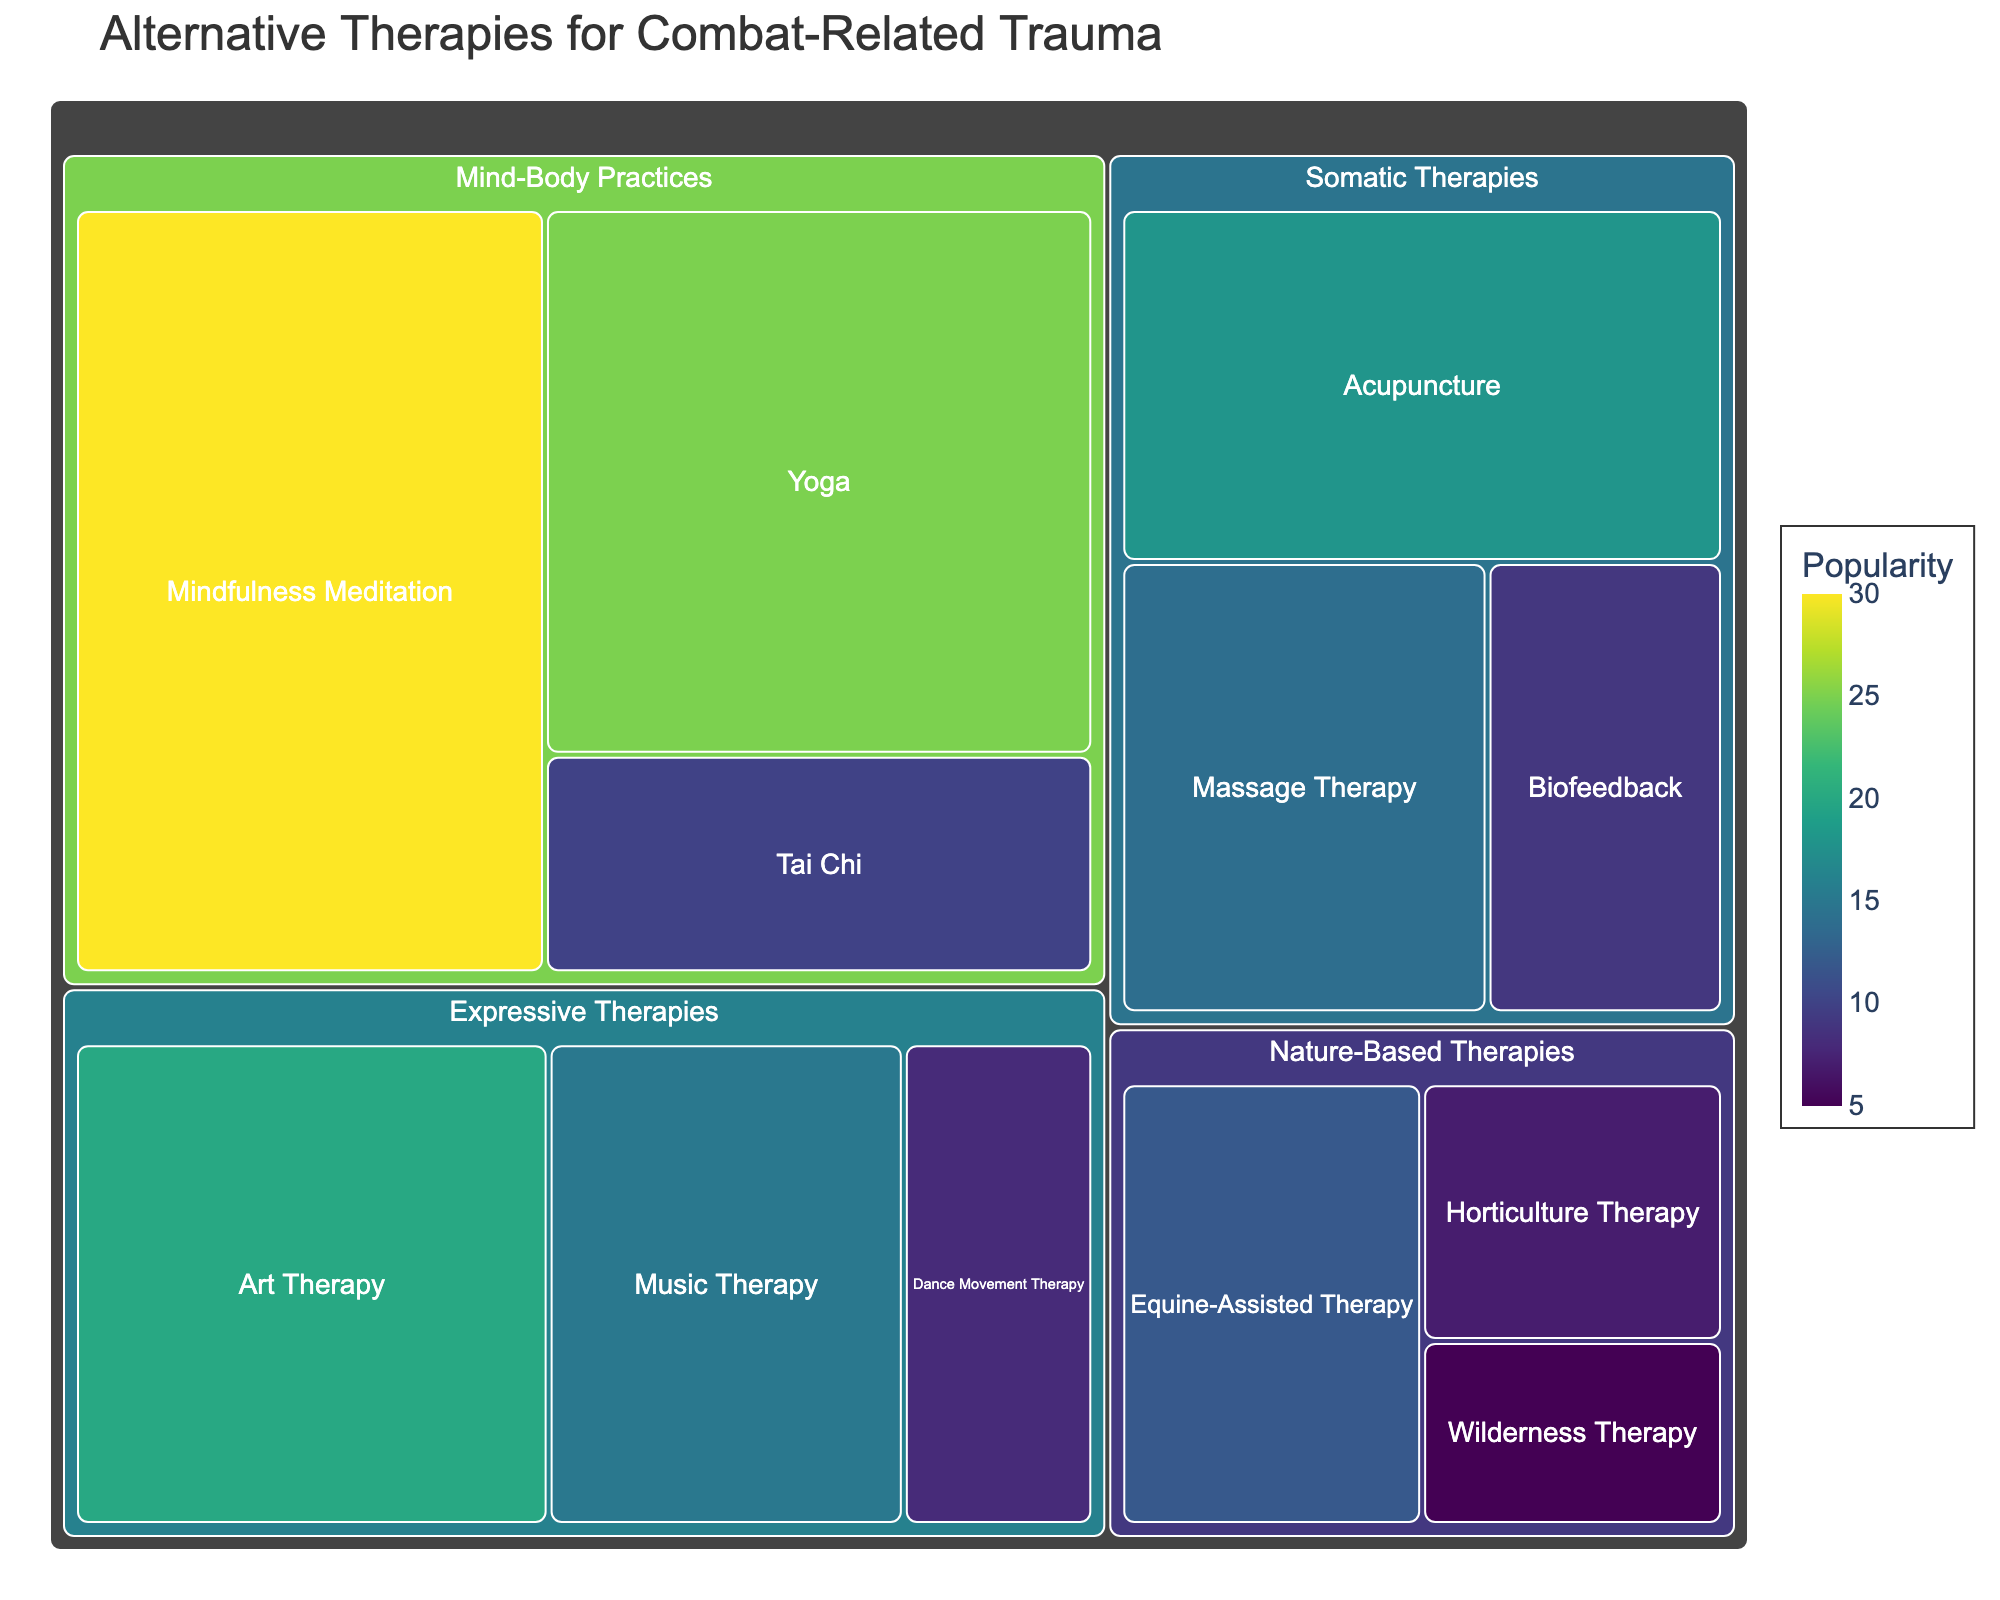Which therapy has the highest popularity among veterans? Look at the largest tile within the Treemap, which indicates the therapy with the highest popularity value. The therapy with the highest popularity is "Mindfulness Meditation" with a popularity score of 30.
Answer: Mindfulness Meditation Which category does "Acupuncture" belong to? Find the tile labeled "Acupuncture" in the Treemap and observe its hierarchical placement. "Acupuncture" belongs to the "Somatic Therapies" category.
Answer: Somatic Therapies What is the combined popularity of all Expressive Therapies? Identify all therapies under the "Expressive Therapies" category and sum up their popularity values: Art Therapy (20) + Music Therapy (15) + Dance Movement Therapy (8). The total is 20 + 15 + 8 = 43.
Answer: 43 Which category has the lowest total popularity among its therapies? Calculate the total popularity for each category. The lowest total can be found by summing the individual popularity scores:
- Mind-Body Practices: 30 + 25 + 10 = 65
- Expressive Therapies: 20 + 15 + 8 = 43
- Nature-Based Therapies: 12 + 7 + 5 = 24
- Somatic Therapies: 18 + 14 + 9 = 41
Nature-Based Therapies has the lowest total popularity of 24.
Answer: Nature-Based Therapies Among therapies in Nature-Based Therapies, which one has the highest popularity? Locate the tiles under "Nature-Based Therapies" and identify the one with the highest popularity value. "Equine-Assisted Therapy" has a popularity score of 12, the highest in this category.
Answer: Equine-Assisted Therapy How many distinct therapies are included in the Treemap? Count each labeled tile within the Treemap to determine the number of distinct therapies. There are 12 distinct therapies.
Answer: 12 Compare the popularity of "Yoga" and "Music Therapy". Which one is more popular? Locate the tiles "Yoga" and "Music Therapy" and compare their popularity values. "Yoga" has a popularity of 25, whereas "Music Therapy" has 15. Therefore, "Yoga" is more popular.
Answer: Yoga What is the average popularity of therapies under Somatic Therapies? Sum the popularity values of therapies in the "Somatic Therapies" category and divide by the number of therapies: (18 + 14 + 9) / 3 = 13.67.
Answer: 13.67 Among all therapies, which is less popular than both "Biofeedback" and "Horticulture Therapy"? Identify the tiles labeled "Biofeedback" (popularity 9) and "Horticulture Therapy" (popularity 7), then look for any therapy with a value lower than both (less than 7). "Wilderness Therapy" with a popularity of 5 is the only one.
Answer: Wilderness Therapy 